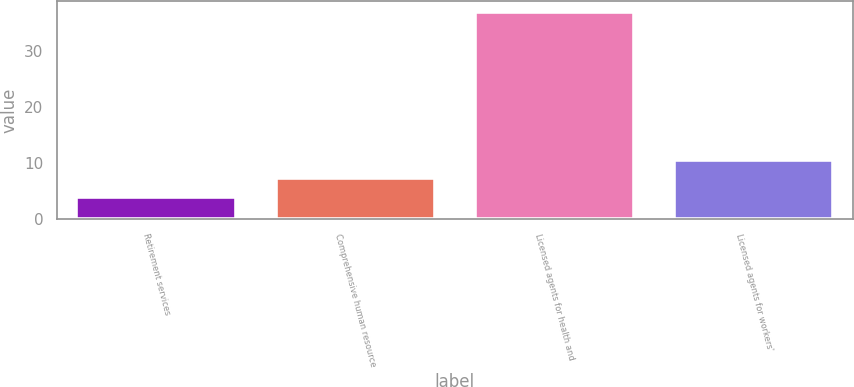Convert chart. <chart><loc_0><loc_0><loc_500><loc_500><bar_chart><fcel>Retirement services<fcel>Comprehensive human resource<fcel>Licensed agents for health and<fcel>Licensed agents for workers'<nl><fcel>4<fcel>7.3<fcel>37<fcel>10.6<nl></chart> 